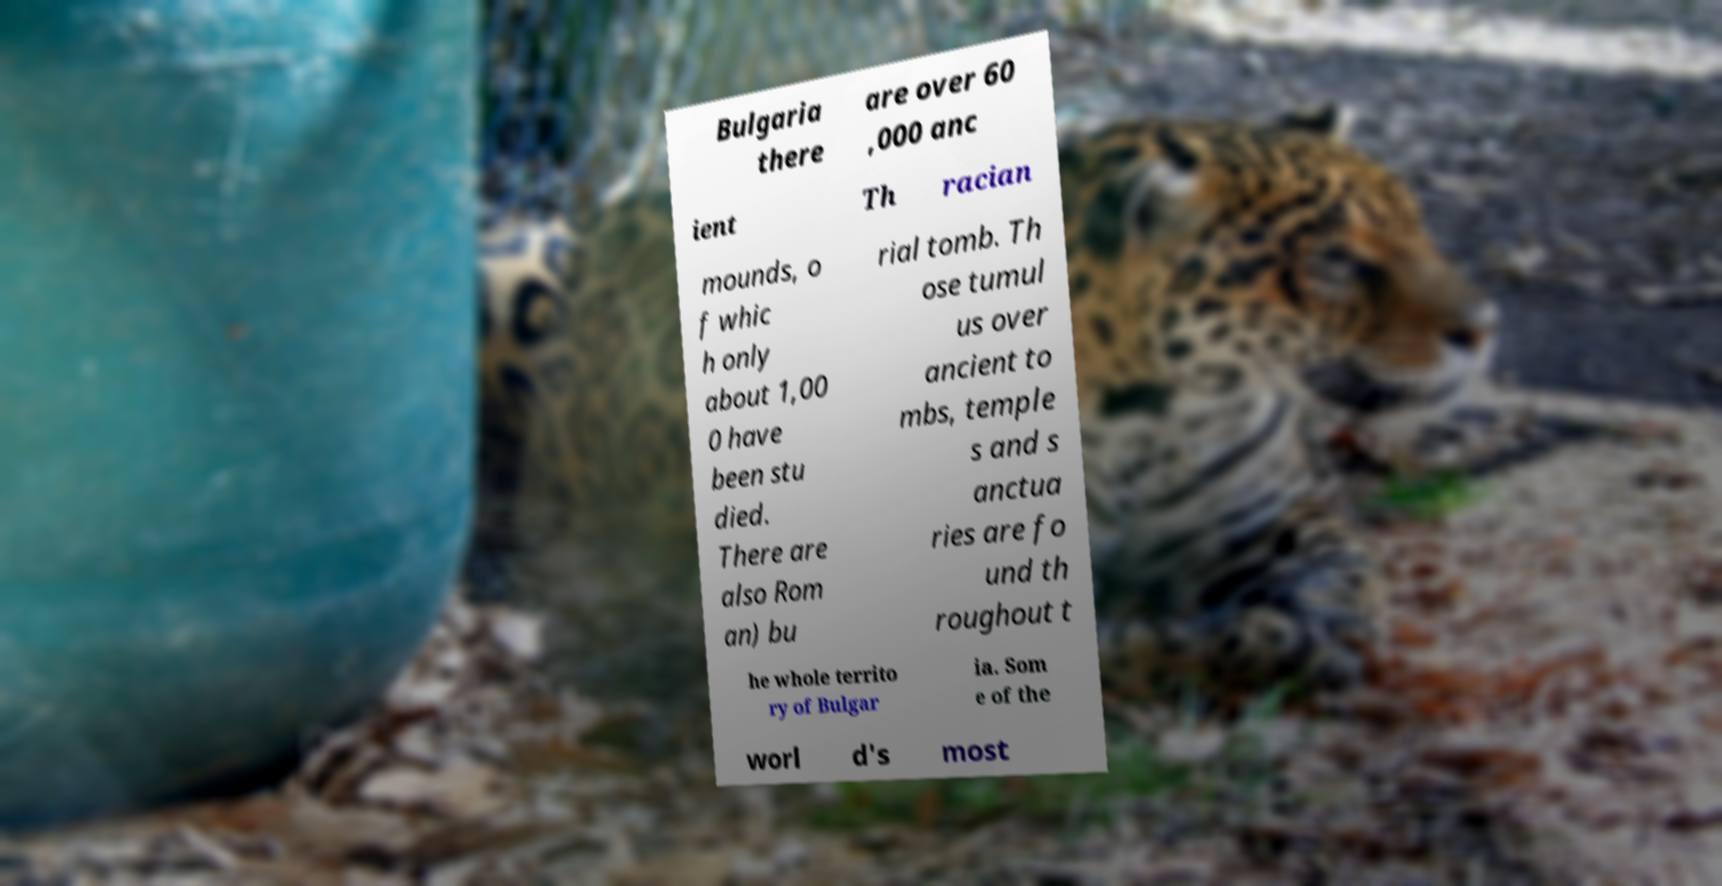I need the written content from this picture converted into text. Can you do that? Bulgaria there are over 60 ,000 anc ient Th racian mounds, o f whic h only about 1,00 0 have been stu died. There are also Rom an) bu rial tomb. Th ose tumul us over ancient to mbs, temple s and s anctua ries are fo und th roughout t he whole territo ry of Bulgar ia. Som e of the worl d's most 